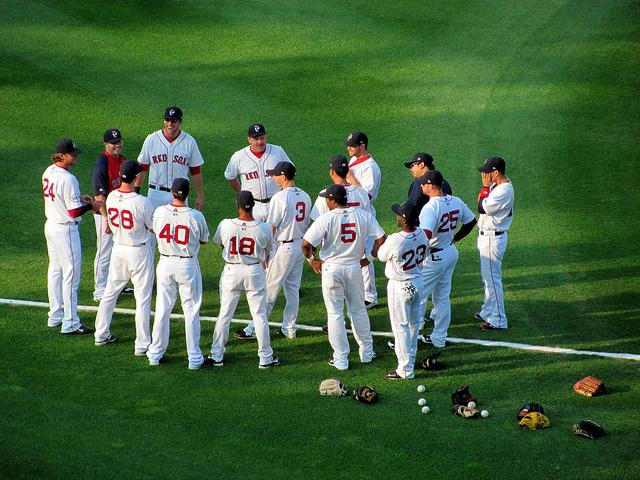Which equipment would be fastest for them to use? bat 